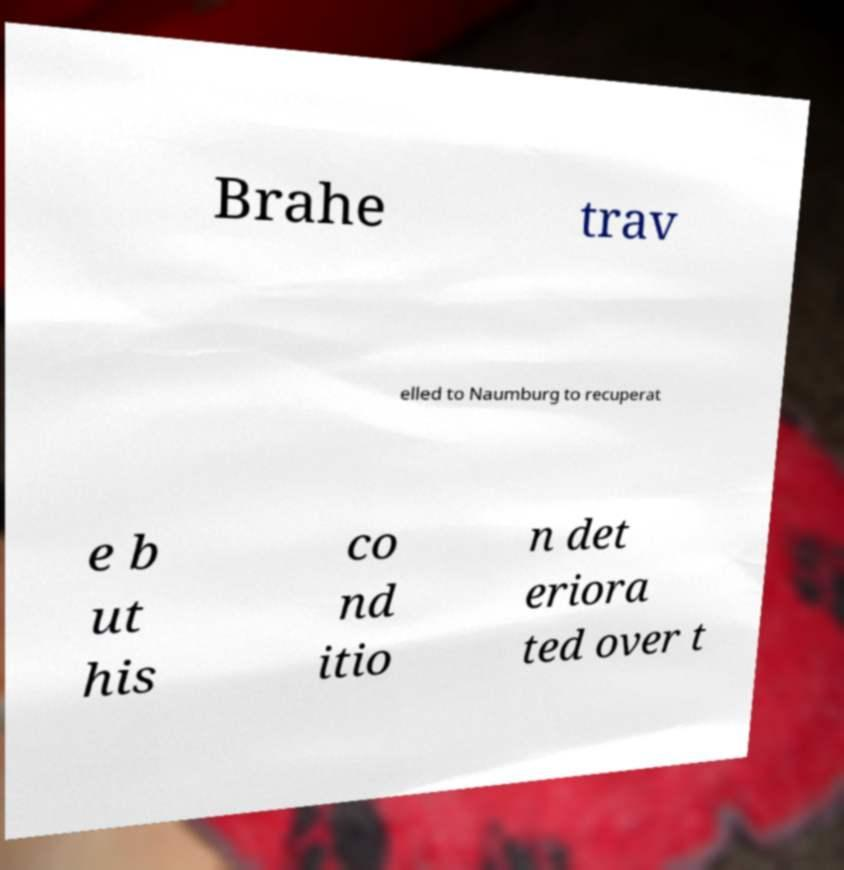Could you extract and type out the text from this image? Brahe trav elled to Naumburg to recuperat e b ut his co nd itio n det eriora ted over t 